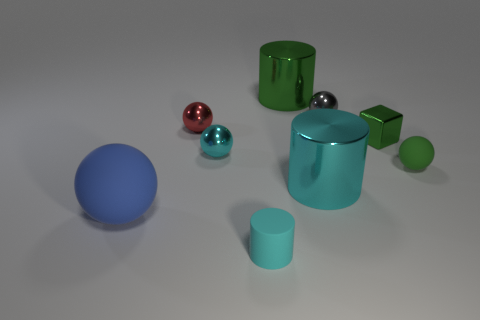Are there more tiny blocks than blue metallic cubes?
Provide a short and direct response. Yes. There is a cylinder behind the green sphere; is it the same color as the small rubber cylinder?
Your answer should be very brief. No. The small cube is what color?
Provide a short and direct response. Green. There is a shiny ball that is in front of the small red ball; are there any green metallic cylinders that are on the left side of it?
Provide a succinct answer. No. There is a cyan object right of the small object that is in front of the small rubber sphere; what shape is it?
Your response must be concise. Cylinder. Are there fewer red metallic balls than small blue shiny blocks?
Offer a very short reply. No. Is the material of the small gray object the same as the large green object?
Provide a short and direct response. Yes. There is a small sphere that is in front of the small green metallic object and to the left of the tiny green shiny cube; what color is it?
Your response must be concise. Cyan. Is there a red matte thing that has the same size as the green shiny cylinder?
Your answer should be compact. No. How big is the matte sphere that is in front of the small rubber object that is right of the tiny cylinder?
Make the answer very short. Large. 